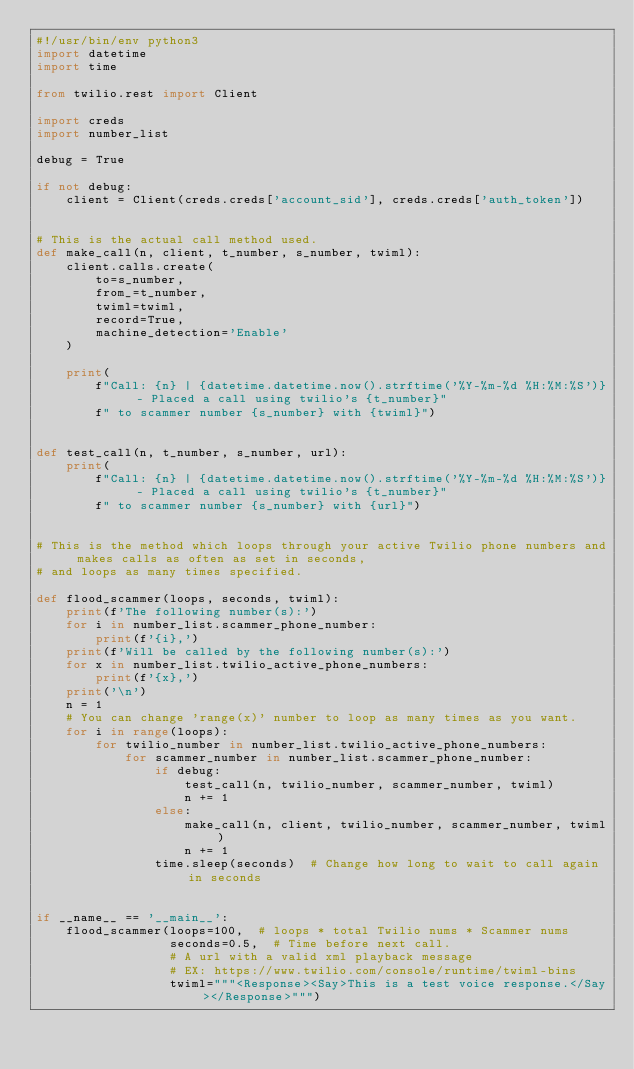<code> <loc_0><loc_0><loc_500><loc_500><_Python_>#!/usr/bin/env python3
import datetime
import time

from twilio.rest import Client

import creds
import number_list

debug = True

if not debug:
    client = Client(creds.creds['account_sid'], creds.creds['auth_token'])


# This is the actual call method used.
def make_call(n, client, t_number, s_number, twiml):
    client.calls.create(
        to=s_number,
        from_=t_number,
        twiml=twiml,
        record=True,
        machine_detection='Enable'
    )

    print(
        f"Call: {n} | {datetime.datetime.now().strftime('%Y-%m-%d %H:%M:%S')} - Placed a call using twilio's {t_number}"
        f" to scammer number {s_number} with {twiml}")


def test_call(n, t_number, s_number, url):
    print(
        f"Call: {n} | {datetime.datetime.now().strftime('%Y-%m-%d %H:%M:%S')} - Placed a call using twilio's {t_number}"
        f" to scammer number {s_number} with {url}")


# This is the method which loops through your active Twilio phone numbers and makes calls as often as set in seconds,
# and loops as many times specified.

def flood_scammer(loops, seconds, twiml):
    print(f'The following number(s):')
    for i in number_list.scammer_phone_number:
        print(f'{i},')
    print(f'Will be called by the following number(s):')
    for x in number_list.twilio_active_phone_numbers:
        print(f'{x},')
    print('\n')
    n = 1
    # You can change 'range(x)' number to loop as many times as you want.
    for i in range(loops):
        for twilio_number in number_list.twilio_active_phone_numbers:
            for scammer_number in number_list.scammer_phone_number:
                if debug:
                    test_call(n, twilio_number, scammer_number, twiml)
                    n += 1
                else:
                    make_call(n, client, twilio_number, scammer_number, twiml)
                    n += 1
                time.sleep(seconds)  # Change how long to wait to call again in seconds


if __name__ == '__main__':
    flood_scammer(loops=100,  # loops * total Twilio nums * Scammer nums
                  seconds=0.5,  # Time before next call.
                  # A url with a valid xml playback message
                  # EX: https://www.twilio.com/console/runtime/twiml-bins
                  twiml="""<Response><Say>This is a test voice response.</Say></Response>""")
</code> 